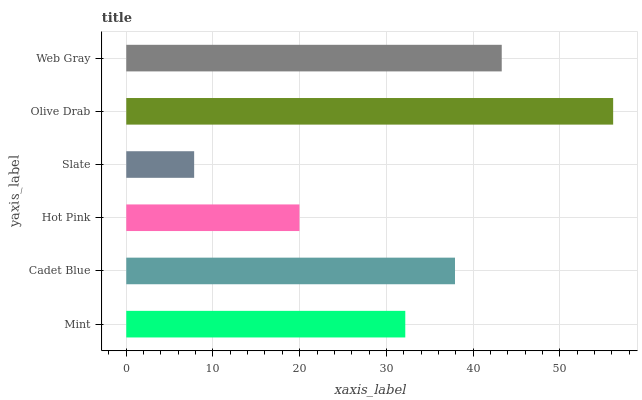Is Slate the minimum?
Answer yes or no. Yes. Is Olive Drab the maximum?
Answer yes or no. Yes. Is Cadet Blue the minimum?
Answer yes or no. No. Is Cadet Blue the maximum?
Answer yes or no. No. Is Cadet Blue greater than Mint?
Answer yes or no. Yes. Is Mint less than Cadet Blue?
Answer yes or no. Yes. Is Mint greater than Cadet Blue?
Answer yes or no. No. Is Cadet Blue less than Mint?
Answer yes or no. No. Is Cadet Blue the high median?
Answer yes or no. Yes. Is Mint the low median?
Answer yes or no. Yes. Is Hot Pink the high median?
Answer yes or no. No. Is Cadet Blue the low median?
Answer yes or no. No. 